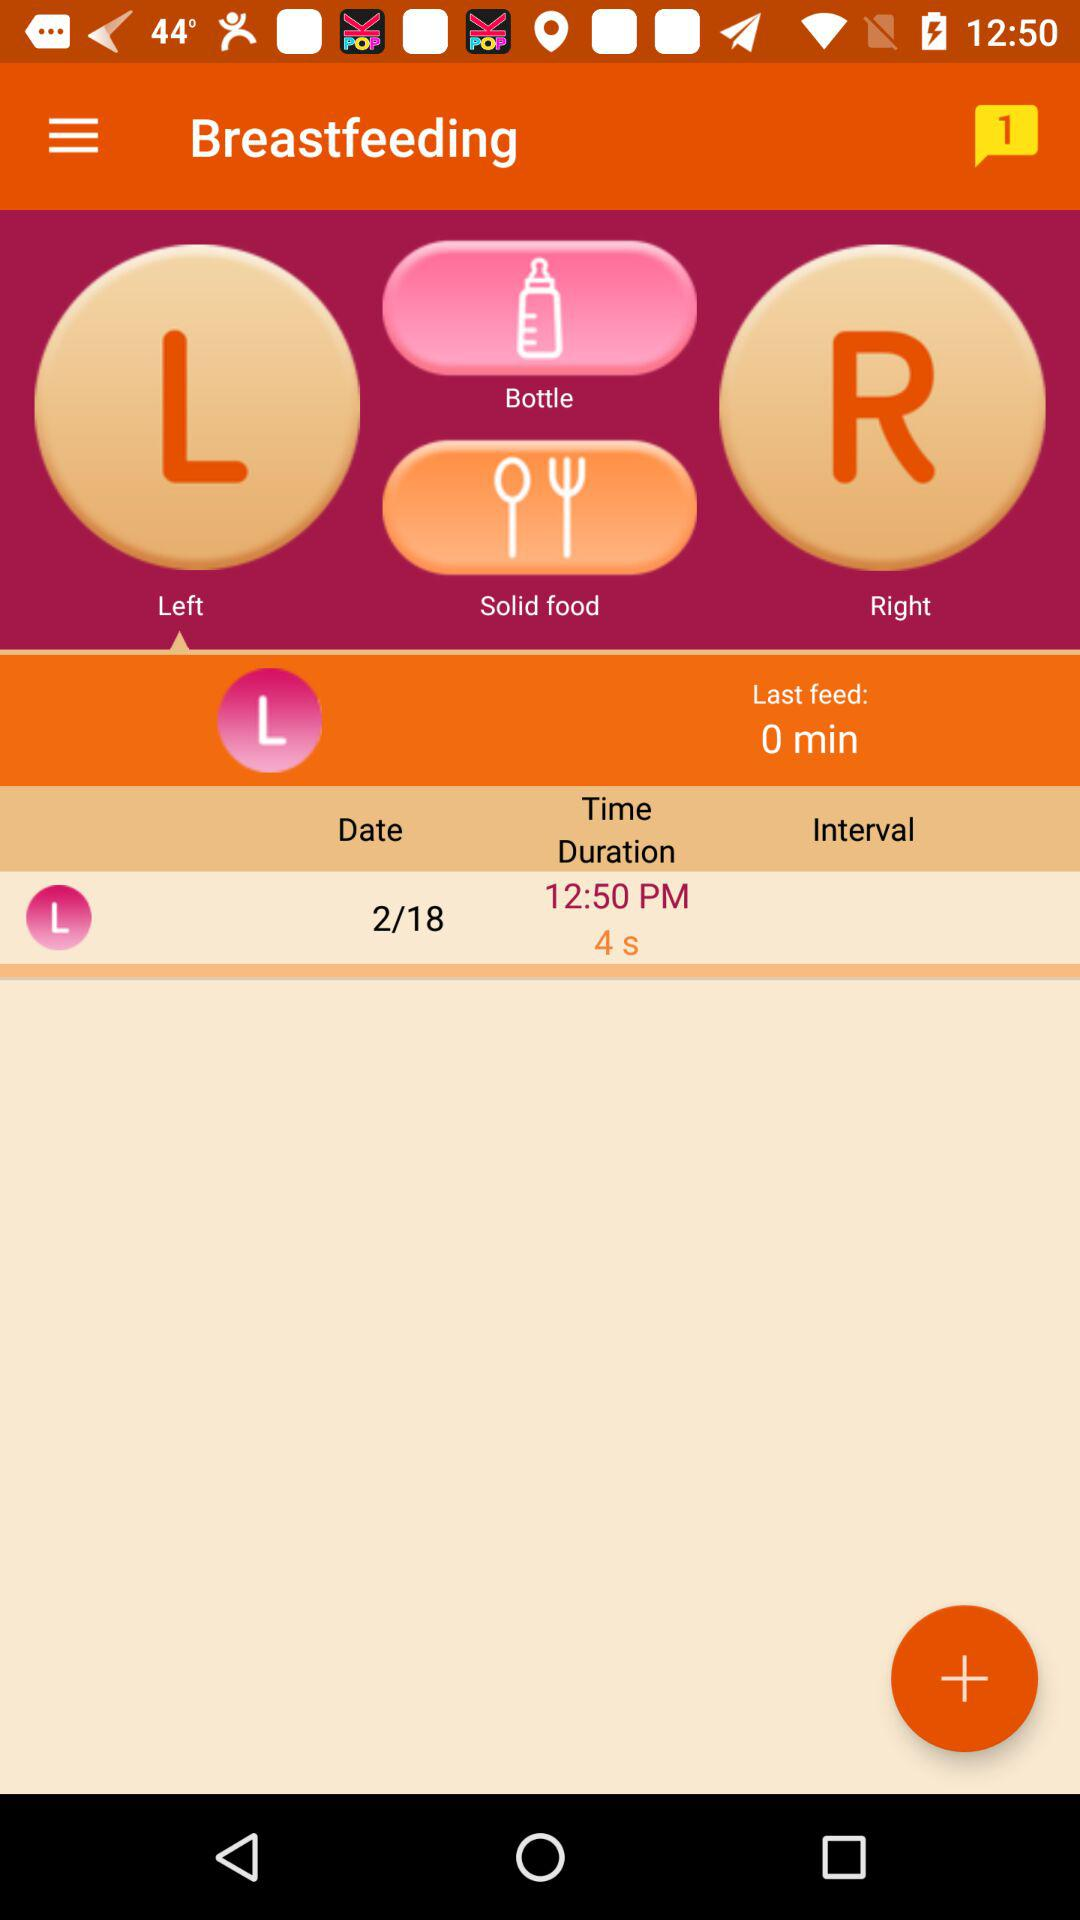What is the time duration of "Last feed"? The time duration of "Last feed" is 0 minutes. 